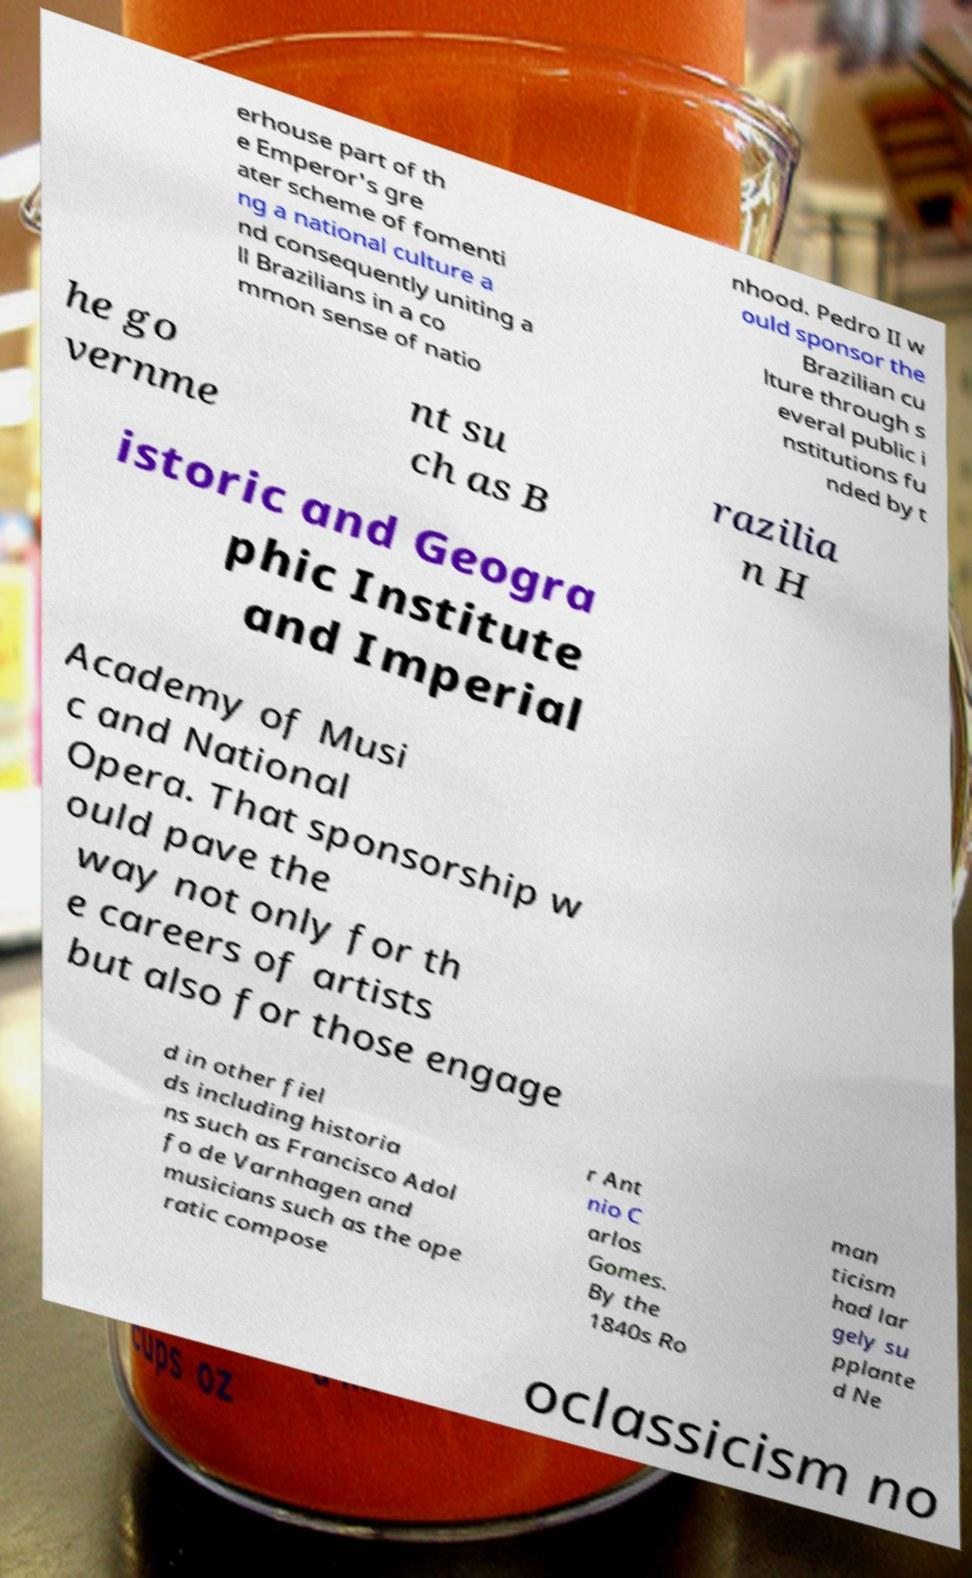Please read and relay the text visible in this image. What does it say? erhouse part of th e Emperor's gre ater scheme of fomenti ng a national culture a nd consequently uniting a ll Brazilians in a co mmon sense of natio nhood. Pedro II w ould sponsor the Brazilian cu lture through s everal public i nstitutions fu nded by t he go vernme nt su ch as B razilia n H istoric and Geogra phic Institute and Imperial Academy of Musi c and National Opera. That sponsorship w ould pave the way not only for th e careers of artists but also for those engage d in other fiel ds including historia ns such as Francisco Adol fo de Varnhagen and musicians such as the ope ratic compose r Ant nio C arlos Gomes. By the 1840s Ro man ticism had lar gely su pplante d Ne oclassicism no 